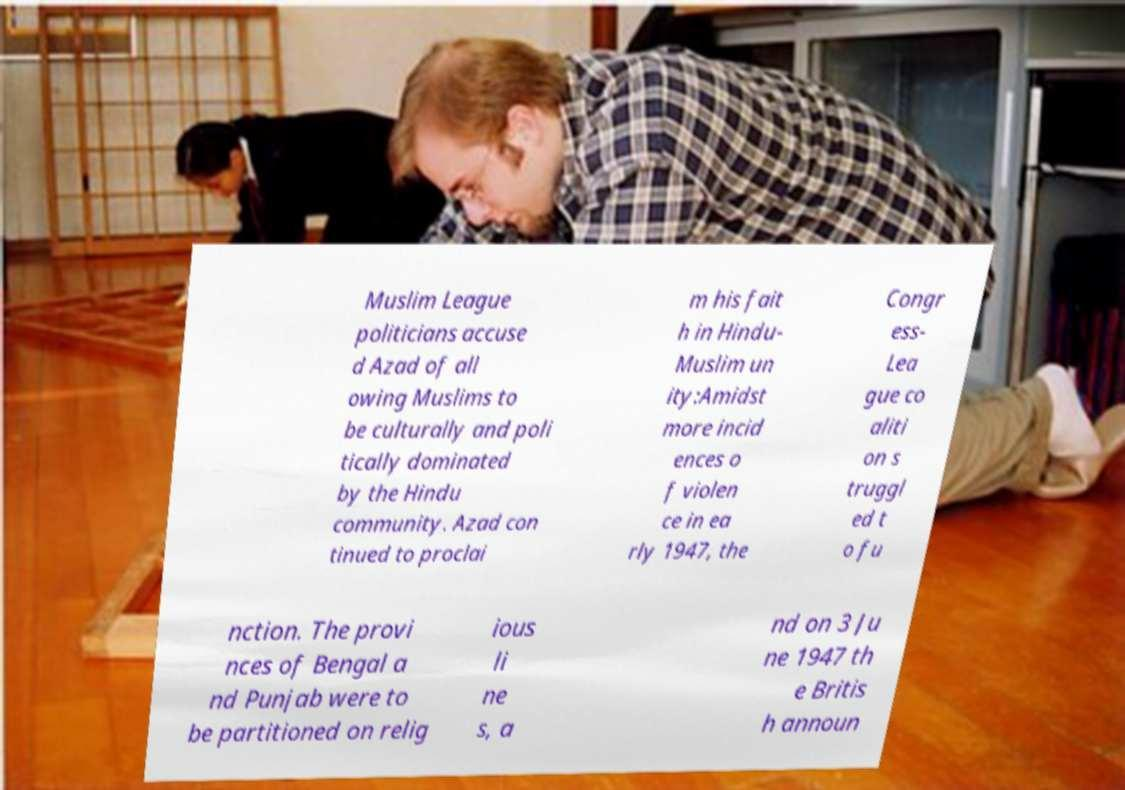Can you accurately transcribe the text from the provided image for me? Muslim League politicians accuse d Azad of all owing Muslims to be culturally and poli tically dominated by the Hindu community. Azad con tinued to proclai m his fait h in Hindu- Muslim un ity:Amidst more incid ences o f violen ce in ea rly 1947, the Congr ess- Lea gue co aliti on s truggl ed t o fu nction. The provi nces of Bengal a nd Punjab were to be partitioned on relig ious li ne s, a nd on 3 Ju ne 1947 th e Britis h announ 